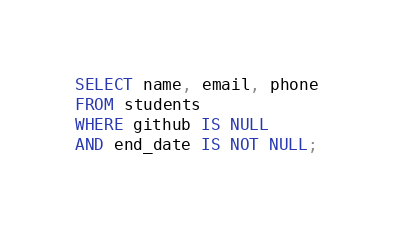<code> <loc_0><loc_0><loc_500><loc_500><_SQL_>SELECT name, email, phone
FROM students 
WHERE github IS NULL
AND end_date IS NOT NULL;
</code> 